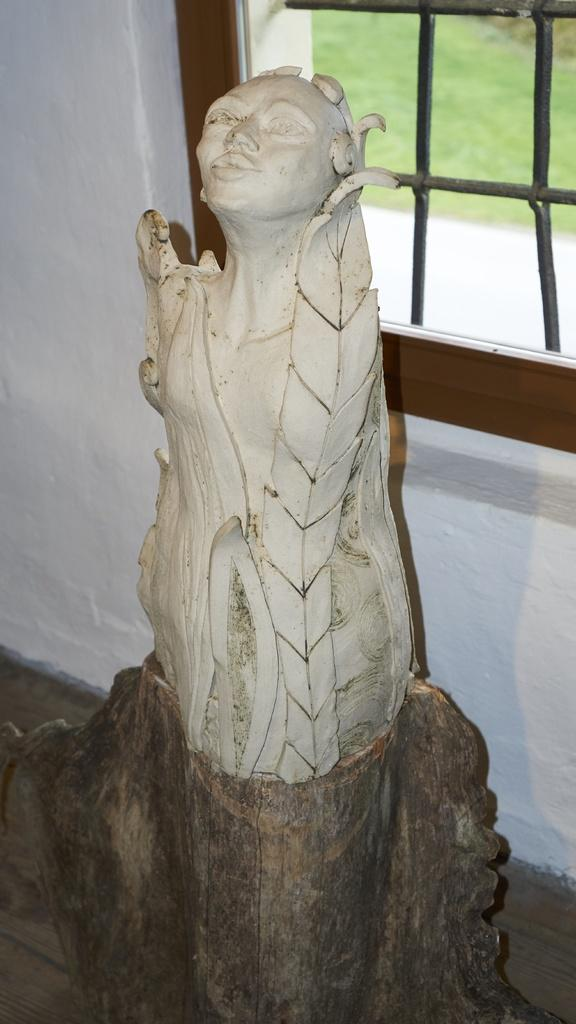What is the main object in the image? There is a statue in the image. What can be seen in the background of the image? There is a white wall and a window in the background of the image. What is present on the floor in the image? There is a grill in the image. What is the surface at the bottom of the image? There is a floor at the bottom of the image. What type of button is on the statue's shirt in the image? There is no button mentioned or visible on the statue's shirt in the image. How many ducks are present in the image? There are no ducks present in the image. 